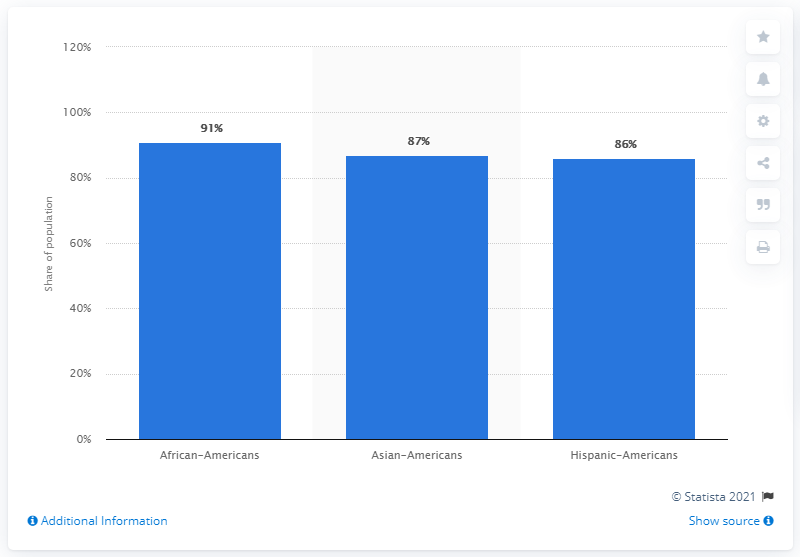Mention a couple of crucial points in this snapshot. The rightmost bar has a value of 86. The difference between the two ethnicities that are more than 86% is 4%. 